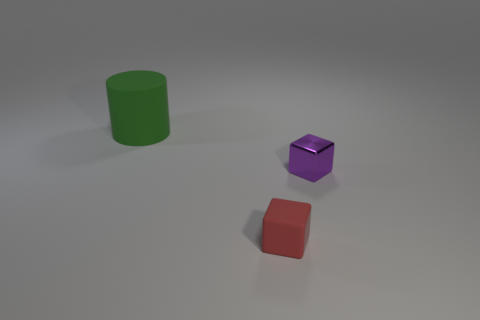Subtract all purple cubes. How many cubes are left? 1 Subtract all cylinders. How many objects are left? 2 Add 3 small red blocks. How many small red blocks exist? 4 Add 2 red matte cubes. How many objects exist? 5 Subtract 0 gray blocks. How many objects are left? 3 Subtract 1 cylinders. How many cylinders are left? 0 Subtract all brown cylinders. Subtract all cyan blocks. How many cylinders are left? 1 Subtract all blue cylinders. How many red cubes are left? 1 Subtract all small metal things. Subtract all rubber cylinders. How many objects are left? 1 Add 2 matte cubes. How many matte cubes are left? 3 